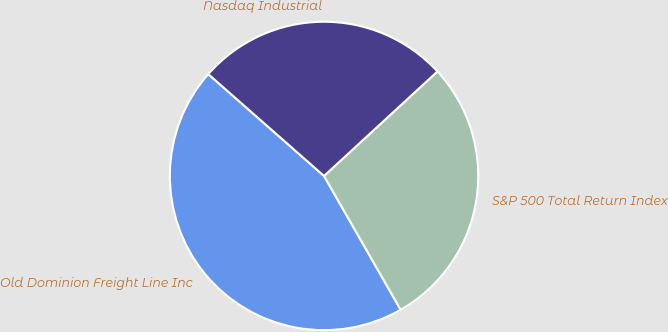Convert chart to OTSL. <chart><loc_0><loc_0><loc_500><loc_500><pie_chart><fcel>Old Dominion Freight Line Inc<fcel>S&P 500 Total Return Index<fcel>Nasdaq Industrial<nl><fcel>44.76%<fcel>28.57%<fcel>26.67%<nl></chart> 